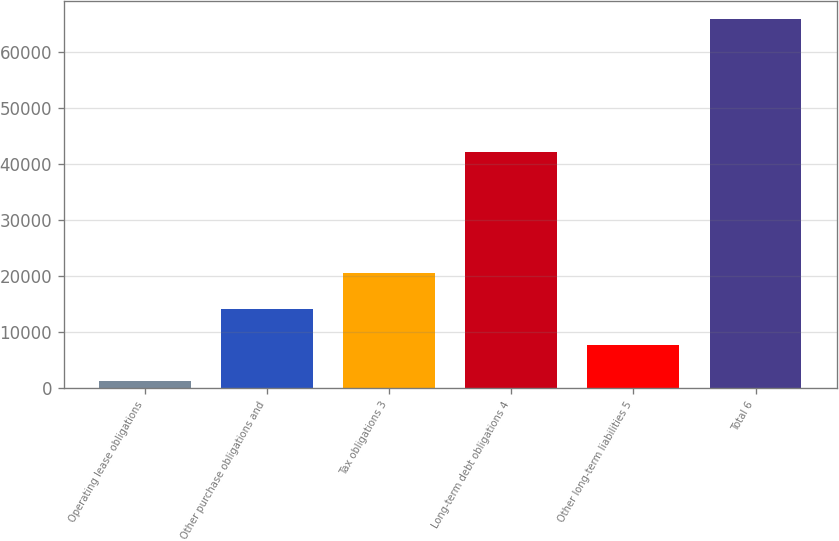Convert chart to OTSL. <chart><loc_0><loc_0><loc_500><loc_500><bar_chart><fcel>Operating lease obligations<fcel>Other purchase obligations and<fcel>Tax obligations 3<fcel>Long-term debt obligations 4<fcel>Other long-term liabilities 5<fcel>Total 6<nl><fcel>1245<fcel>14185.4<fcel>20655.6<fcel>42278<fcel>7715.2<fcel>65947<nl></chart> 